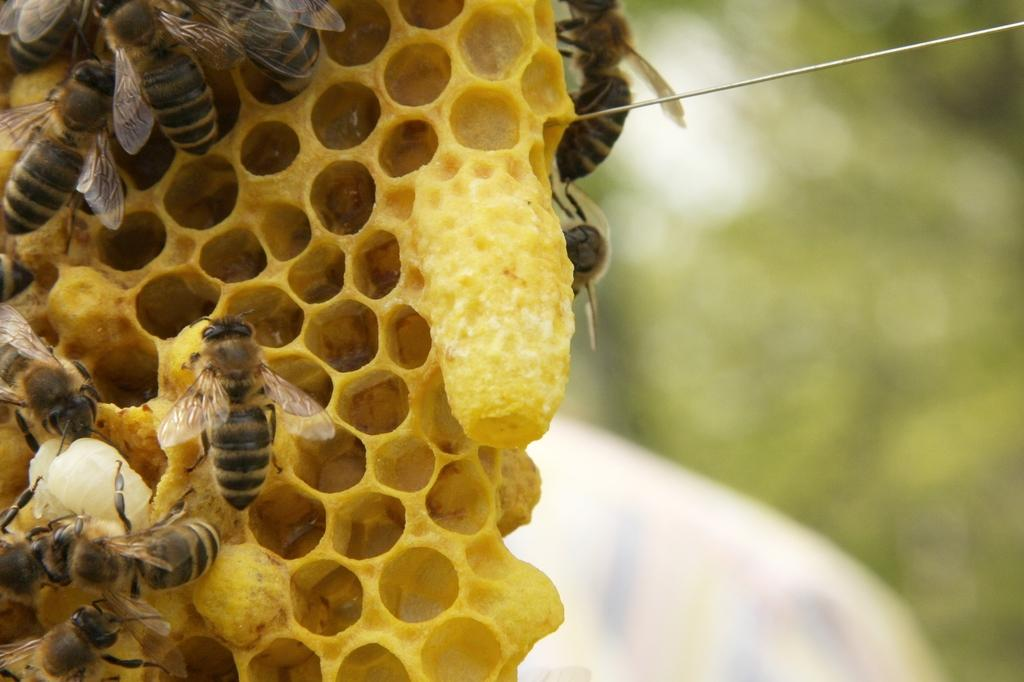What type of insects can be seen in the image? There are honey bees in the image. What color is the object in the image? The object in the image is yellow in color. How would you describe the background of the image? The background of the image is blurry. What type of coil is being used for the mother's treatment in the image? There is no coil or mother present in the image; it features honey bees and a yellow object with a blurry background. 